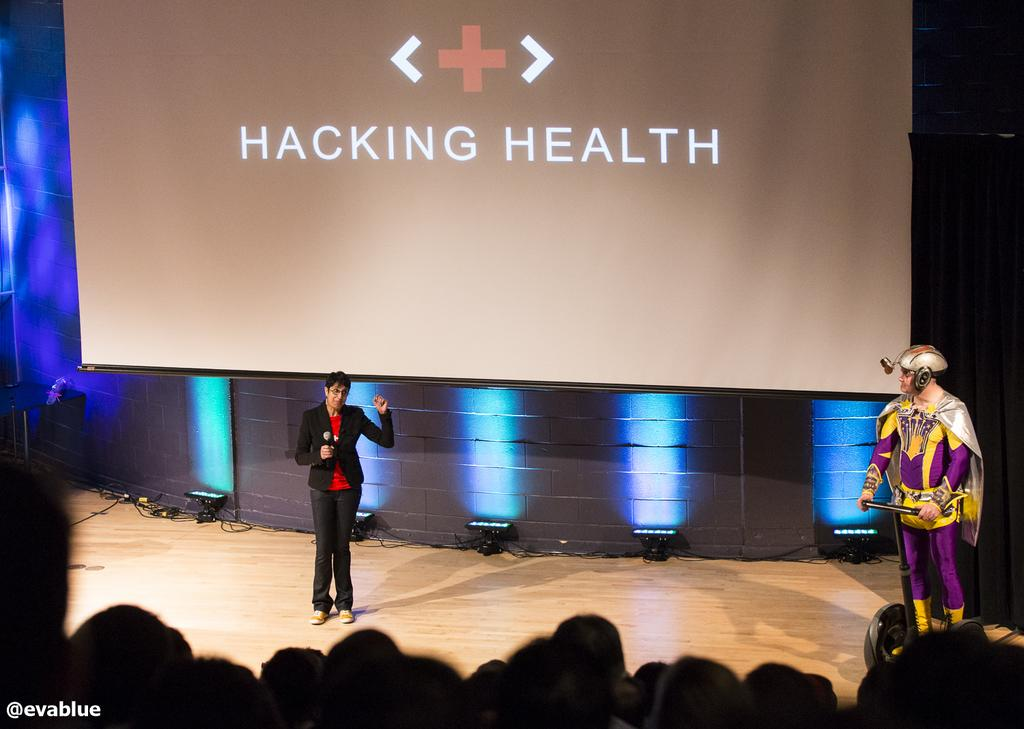What is the person in the image doing? The person is standing in the image. What is the person wearing? The person is wearing a black blazer and a red shirt. What object is the person holding? The person is holding a microphone. What can be seen in the background of the image? There is a projector screen and lights in blue color in the background. How many volleyballs are visible on the projector screen in the image? There are no volleyballs visible on the projector screen in the image. What type of twig is being used as a prop by the person in the image? There is no twig present in the image. 